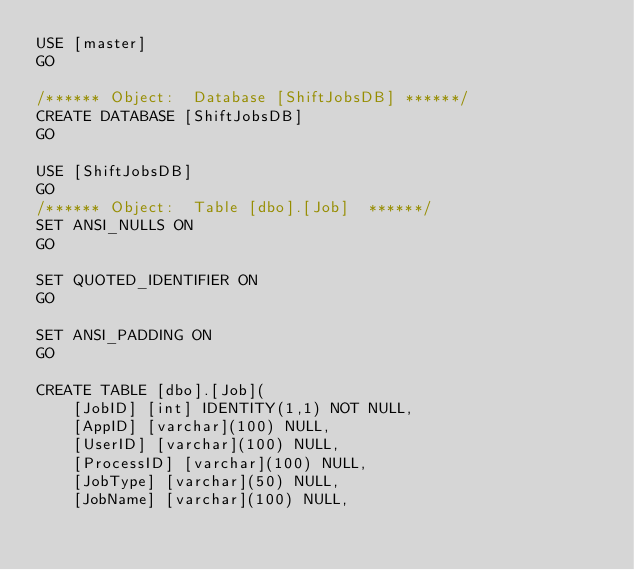Convert code to text. <code><loc_0><loc_0><loc_500><loc_500><_SQL_>USE [master]
GO

/****** Object:  Database [ShiftJobsDB] ******/
CREATE DATABASE [ShiftJobsDB] 
GO

USE [ShiftJobsDB]
GO
/****** Object:  Table [dbo].[Job]  ******/
SET ANSI_NULLS ON
GO

SET QUOTED_IDENTIFIER ON
GO

SET ANSI_PADDING ON
GO

CREATE TABLE [dbo].[Job](
	[JobID] [int] IDENTITY(1,1) NOT NULL,
	[AppID] [varchar](100) NULL,
	[UserID] [varchar](100) NULL,
	[ProcessID] [varchar](100) NULL,
	[JobType] [varchar](50) NULL,
	[JobName] [varchar](100) NULL,</code> 